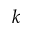Convert formula to latex. <formula><loc_0><loc_0><loc_500><loc_500>k</formula> 